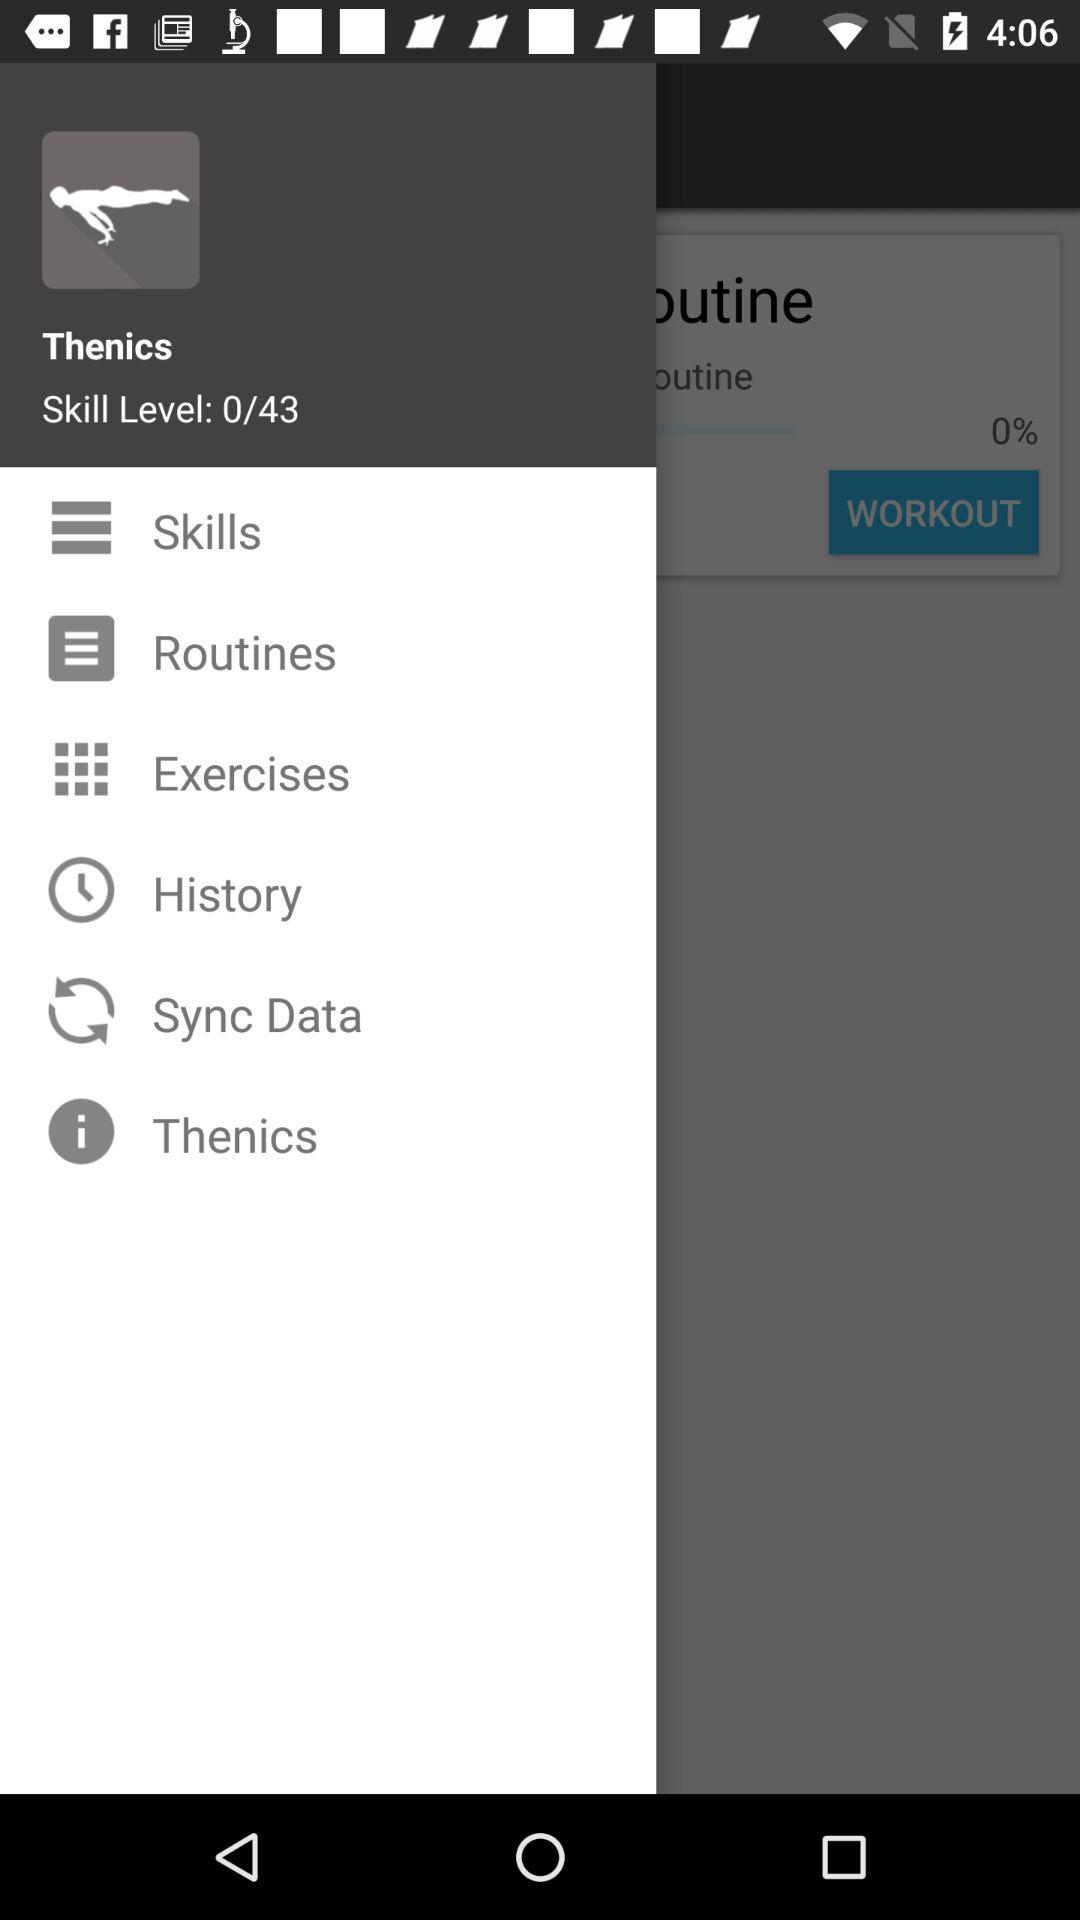What is the skill level? The skill level is 0. 